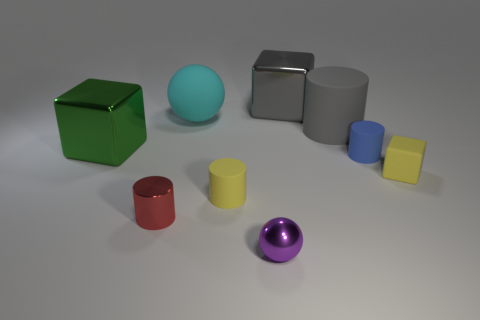How many other things are there of the same shape as the small purple shiny thing?
Offer a very short reply. 1. Are there any other things that are the same material as the big cylinder?
Give a very brief answer. Yes. What is the color of the small matte cylinder right of the small metallic thing right of the large cyan thing in front of the gray metallic thing?
Give a very brief answer. Blue. Is the shape of the small yellow matte object that is to the right of the tiny yellow matte cylinder the same as  the tiny purple shiny object?
Offer a terse response. No. How many small matte cylinders are there?
Provide a succinct answer. 2. What number of yellow rubber cylinders have the same size as the purple thing?
Offer a very short reply. 1. What is the material of the green thing?
Your answer should be compact. Metal. There is a big ball; does it have the same color as the tiny metallic object that is behind the purple sphere?
Your answer should be very brief. No. Are there any other things that are the same size as the cyan matte ball?
Your answer should be compact. Yes. There is a object that is on the left side of the big cyan object and behind the small blue cylinder; what size is it?
Your answer should be very brief. Large. 